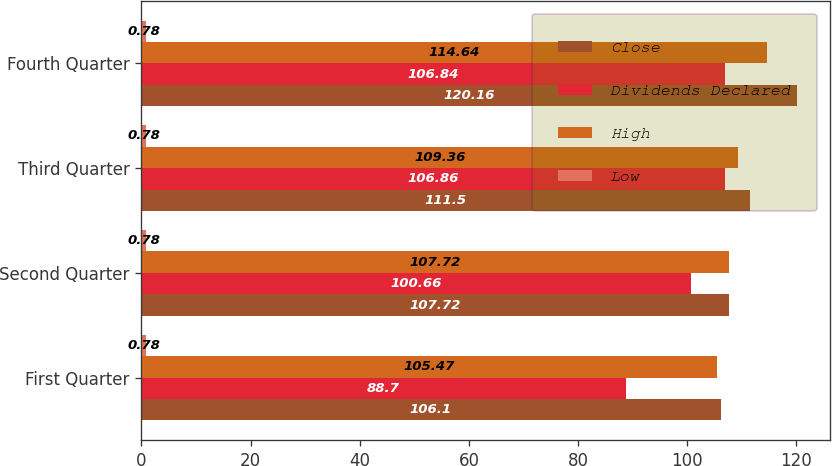Convert chart. <chart><loc_0><loc_0><loc_500><loc_500><stacked_bar_chart><ecel><fcel>First Quarter<fcel>Second Quarter<fcel>Third Quarter<fcel>Fourth Quarter<nl><fcel>Close<fcel>106.1<fcel>107.72<fcel>111.5<fcel>120.16<nl><fcel>Dividends Declared<fcel>88.7<fcel>100.66<fcel>106.86<fcel>106.84<nl><fcel>High<fcel>105.47<fcel>107.72<fcel>109.36<fcel>114.64<nl><fcel>Low<fcel>0.78<fcel>0.78<fcel>0.78<fcel>0.78<nl></chart> 